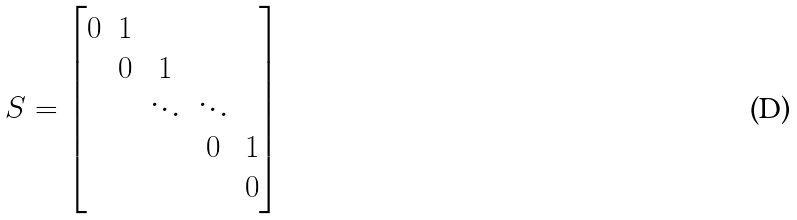Convert formula to latex. <formula><loc_0><loc_0><loc_500><loc_500>S = \begin{bmatrix} 0 & 1 & & & \\ & 0 & 1 & & \\ & & \ddots & \ddots & \\ & & & 0 & 1 \\ & & & & 0 \end{bmatrix}</formula> 